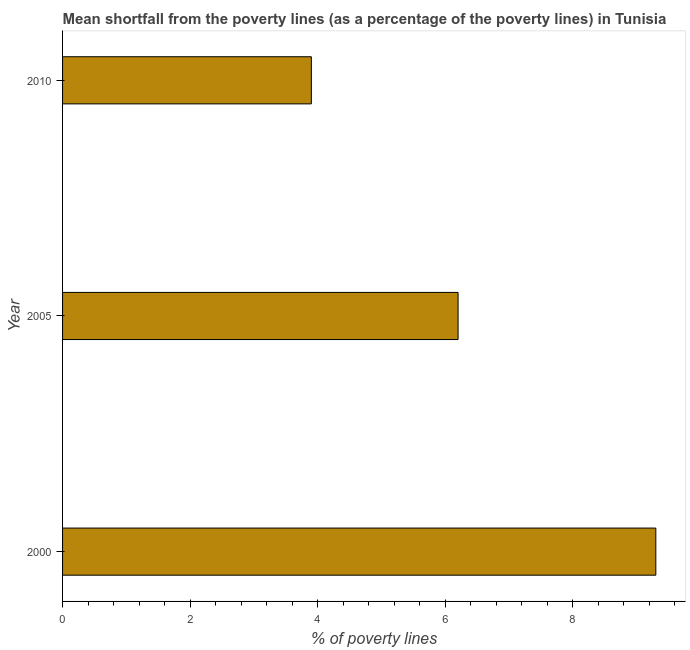Does the graph contain any zero values?
Ensure brevity in your answer.  No. What is the title of the graph?
Keep it short and to the point. Mean shortfall from the poverty lines (as a percentage of the poverty lines) in Tunisia. What is the label or title of the X-axis?
Your answer should be compact. % of poverty lines. What is the poverty gap at national poverty lines in 2000?
Your response must be concise. 9.3. Across all years, what is the minimum poverty gap at national poverty lines?
Keep it short and to the point. 3.9. What is the difference between the poverty gap at national poverty lines in 2000 and 2010?
Offer a terse response. 5.4. What is the average poverty gap at national poverty lines per year?
Give a very brief answer. 6.47. In how many years, is the poverty gap at national poverty lines greater than 3.6 %?
Offer a terse response. 3. What is the ratio of the poverty gap at national poverty lines in 2000 to that in 2010?
Offer a terse response. 2.38. Is the sum of the poverty gap at national poverty lines in 2000 and 2010 greater than the maximum poverty gap at national poverty lines across all years?
Your answer should be compact. Yes. What is the difference between the highest and the lowest poverty gap at national poverty lines?
Offer a terse response. 5.4. How many bars are there?
Offer a terse response. 3. How many years are there in the graph?
Your answer should be very brief. 3. Are the values on the major ticks of X-axis written in scientific E-notation?
Your answer should be very brief. No. What is the % of poverty lines in 2005?
Your response must be concise. 6.2. What is the difference between the % of poverty lines in 2005 and 2010?
Provide a short and direct response. 2.3. What is the ratio of the % of poverty lines in 2000 to that in 2010?
Provide a short and direct response. 2.38. What is the ratio of the % of poverty lines in 2005 to that in 2010?
Your response must be concise. 1.59. 